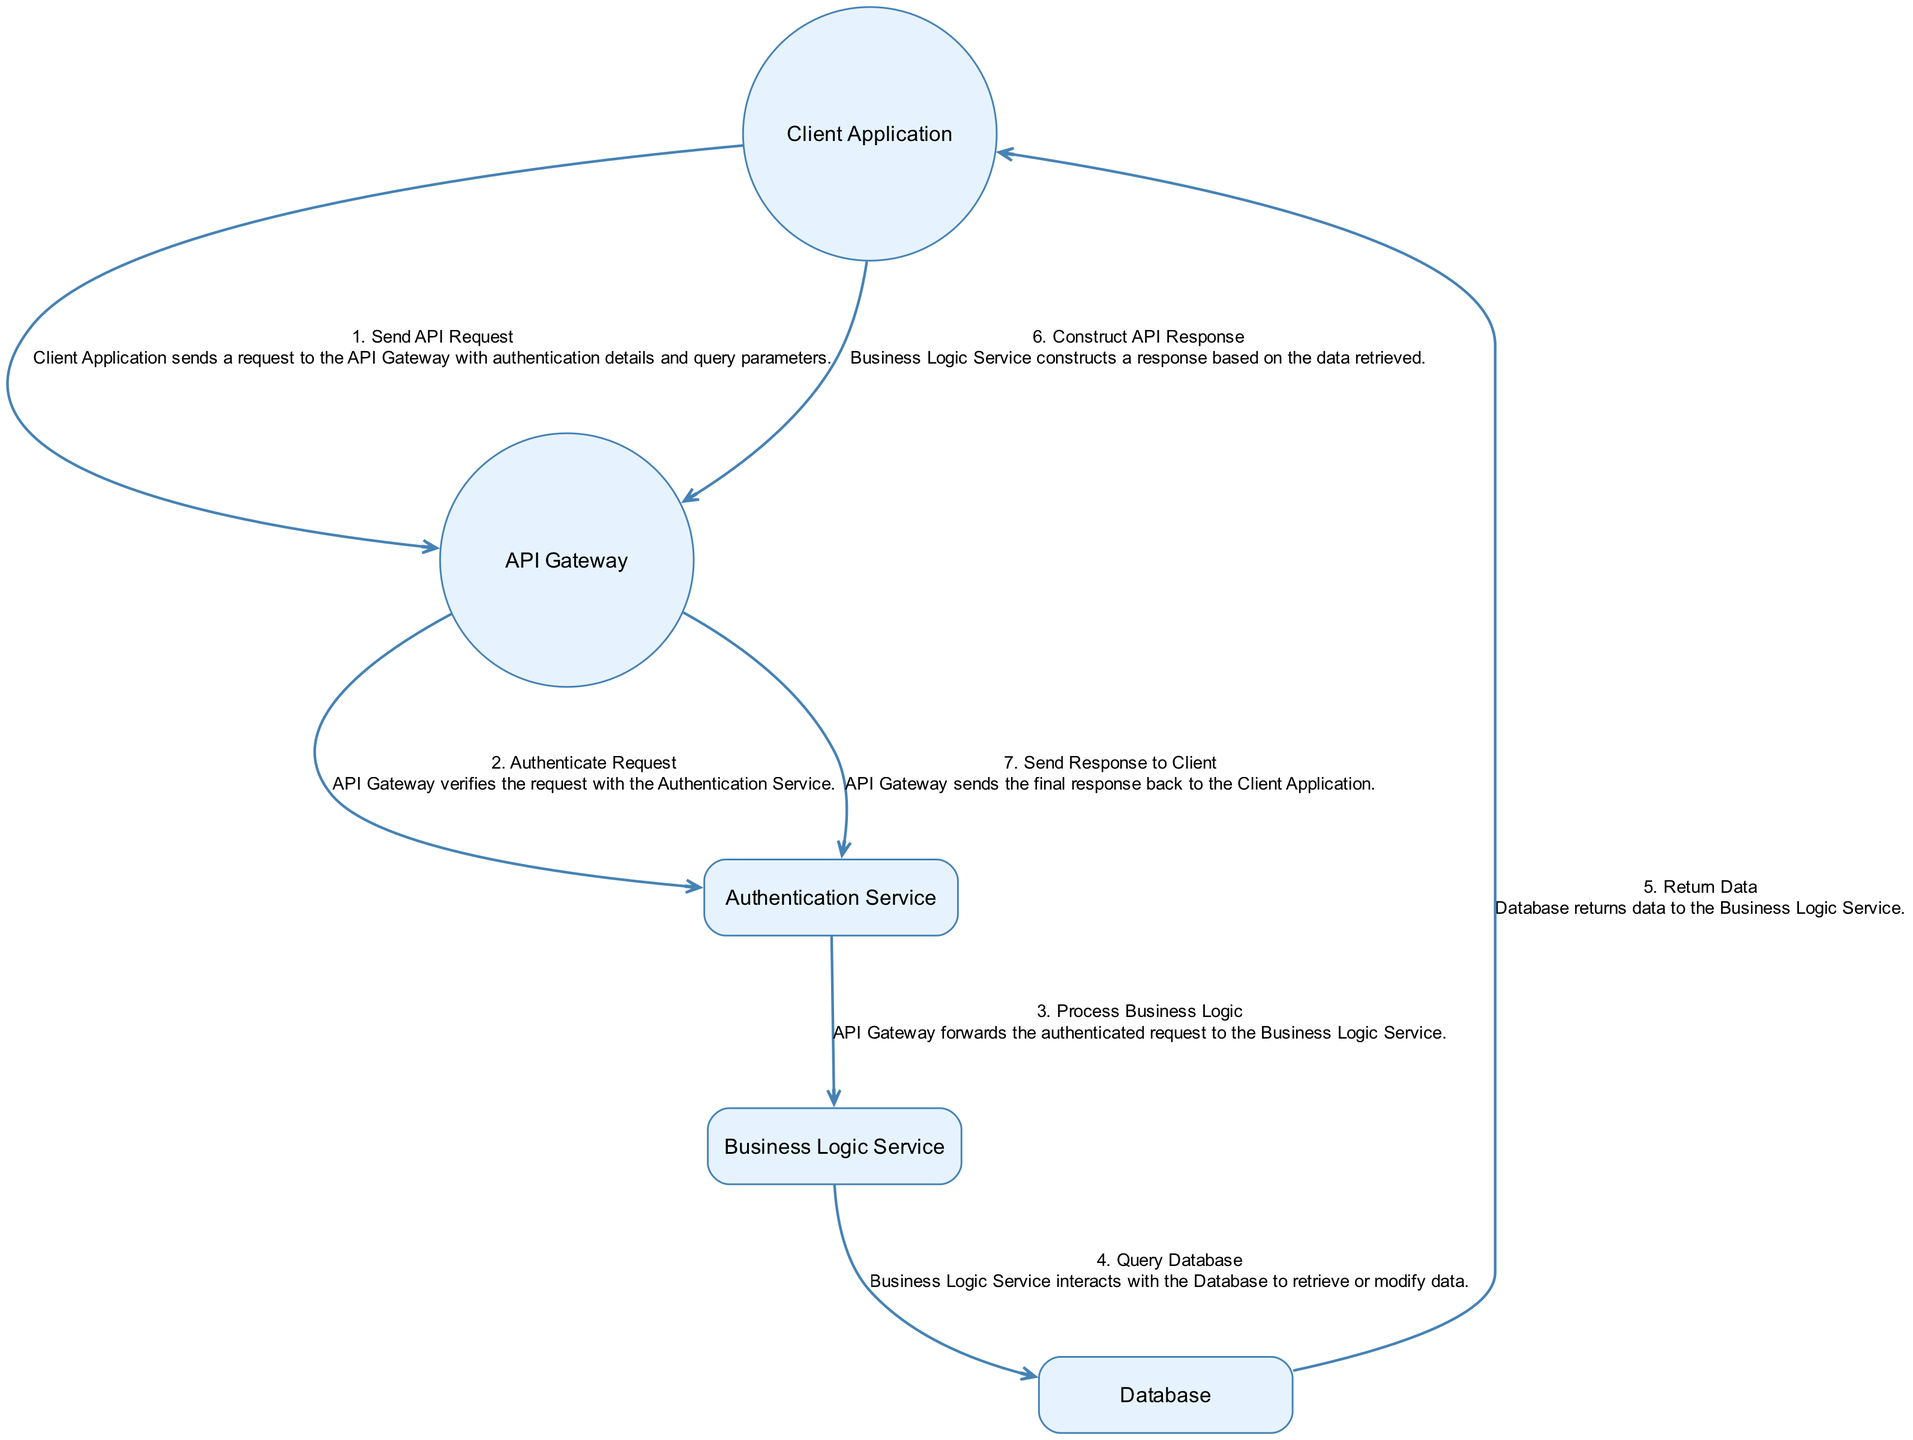What is the total number of actors in the diagram? The diagram includes the "Client Application" and "API Gateway" as actors. Therefore, count these two elements to find the total number of actors, which is 2.
Answer: 2 Which service does the API Gateway authenticate the request with? The action "Authenticate Request" indicates that the API Gateway verifies the request with the "Authentication Service." This direct relationship provides the answer.
Answer: Authentication Service What action comes immediately after the "Send API Request" action? The sequence of actions shows that after "Send API Request," the next action is "Authenticate Request," as it is the immediately following action in the diagram.
Answer: Authenticate Request How many total actions are represented in the diagram? By counting the defined actions, there are a total of 7 actions listed: "Send API Request," "Authenticate Request," "Process Business Logic," "Query Database," "Return Data," "Construct API Response," and "Send Response to Client." Thus, the total is 7.
Answer: 7 What is the last action in the sequence before the response is sent back to the client? The final action is "Send Response to Client," which is performed by the API Gateway, making it the last action in the sequence before the response is returned.
Answer: Send Response to Client Which entity interacts with the Database? The action "Query Database" states that the "Business Logic Service" interacts with the Database to either retrieve or modify data, indicating the responsible entity for this action.
Answer: Business Logic Service How does the data flow after the "Return Data" action? Once the "Return Data" action is executed by the Database, the flow continues with "Construct API Response" being the next action, signifying that the data is then used by the Business Logic Service to build a response.
Answer: Construct API Response What type of diagram is being presented? The structure and the sequential nature of the interactions indicate that this diagram represents a sequence diagram focused on the API request and response lifecycle.
Answer: Sequence Diagram 